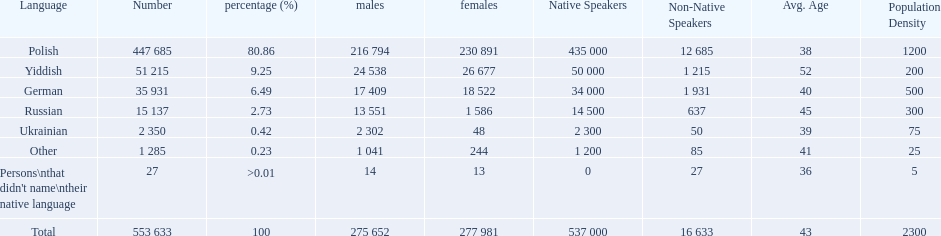How many speakers are represented in polish? 447 685. How many represented speakers are yiddish? 51 215. What is the total number of speakers? 553 633. 